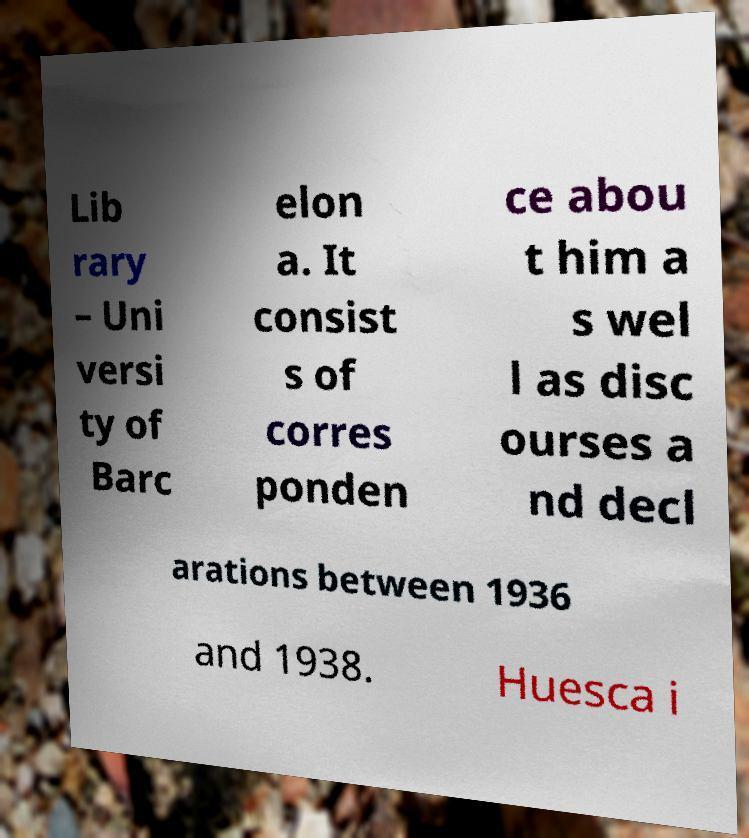I need the written content from this picture converted into text. Can you do that? Lib rary – Uni versi ty of Barc elon a. It consist s of corres ponden ce abou t him a s wel l as disc ourses a nd decl arations between 1936 and 1938. Huesca i 